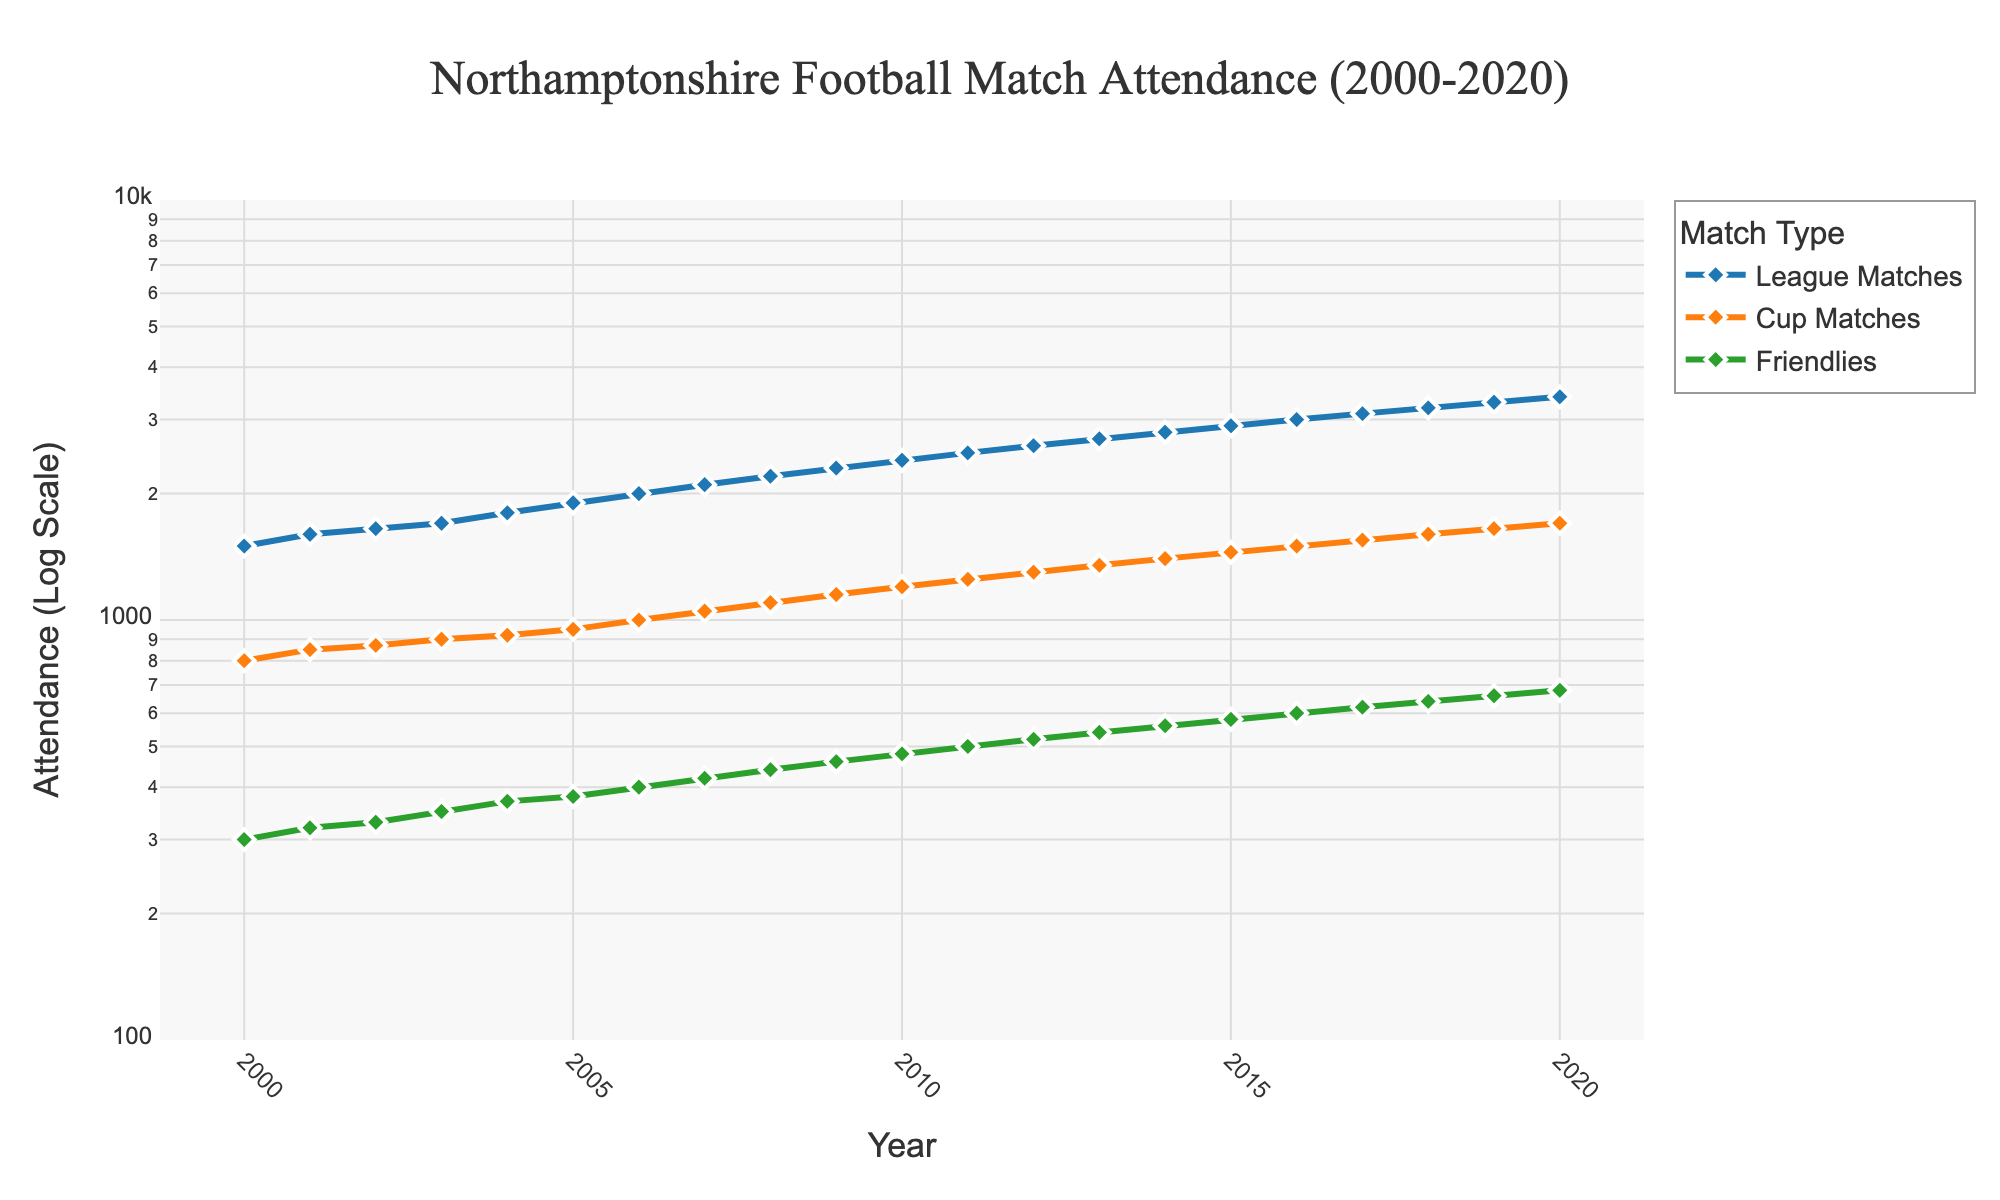What's the title of the plot? The title is displayed at the top center of the plot. It reads "Northamptonshire Football Match Attendance (2000-2020)".
Answer: Northamptonshire Football Match Attendance (2000-2020) Which match type had the highest attendance in 2011? To find the answer, locate the year 2011 on the x-axis and look at the y-values for the three match types. The league matches have the y-value of 2500, which is higher than cup (1250) and friendlies (500).
Answer: League Matches How did the attendance for league matches change from 2005 to 2010? Locate the data points for league matches in the years 2005 and 2010 on the plot. In 2005, the attendance was 1900, and in 2010, it was 2400. The difference is 2400 - 1900.
Answer: Increased by 500 Between 2000 and 2020, which match type had the slowest growth rate in attendance? By comparing the slopes of the lines for each match type in a log scale plot, friendlies have the least steep slope, indicating the slowest growth rate in attendance.
Answer: Friendlies What's the general trend of attendance at Northamptonshire football matches since 2000? Observing the plot, all match types show an increasing trend in attendance over the years from 2000 to 2020.
Answer: Increasing Which year saw the greatest increase in attendance for cup matches? By examining the plot, find the steepest increase in the line for cup matches (orange line). Between 2004 and 2005, the attendance increased from 920 to 950, the highest yearly increment.
Answer: 2005 By how much did the attendance at friendlies increase from 2000 to 2020? Look at the attendance for friendlies in 2000 (300) and in 2020 (680). The increase is 680 - 300.
Answer: 380 In which years did the attendance for league matches exceed 3000? Refer to the green line, marking the years when the attendance crossed the 3000 mark. This happens in 2016, 2017, 2018, 2019, and 2020.
Answer: 2016, 2017, 2018, 2019, 2020 What's the ratio of attendance between league matches and cup matches in 2015? For 2015, the attendance for league matches is 2900, and for cup matches, it is 1450. The ratio is 2900/1450.
Answer: 2:1 Which match type saw an attendance of 1200, and in which year? On the plot, the line for cup matches (orange line) crosses the 1200 mark in 2010.
Answer: Cup Matches, 2010 How does the attendance growth pattern in friendlies compare to league matches over the years? Compare the slopes of the lines for friendlies (green) and league matches (blue) in the log plot. League matches have a steeper slope, indicating higher growth.
Answer: Friendlies grow slower than league matches 